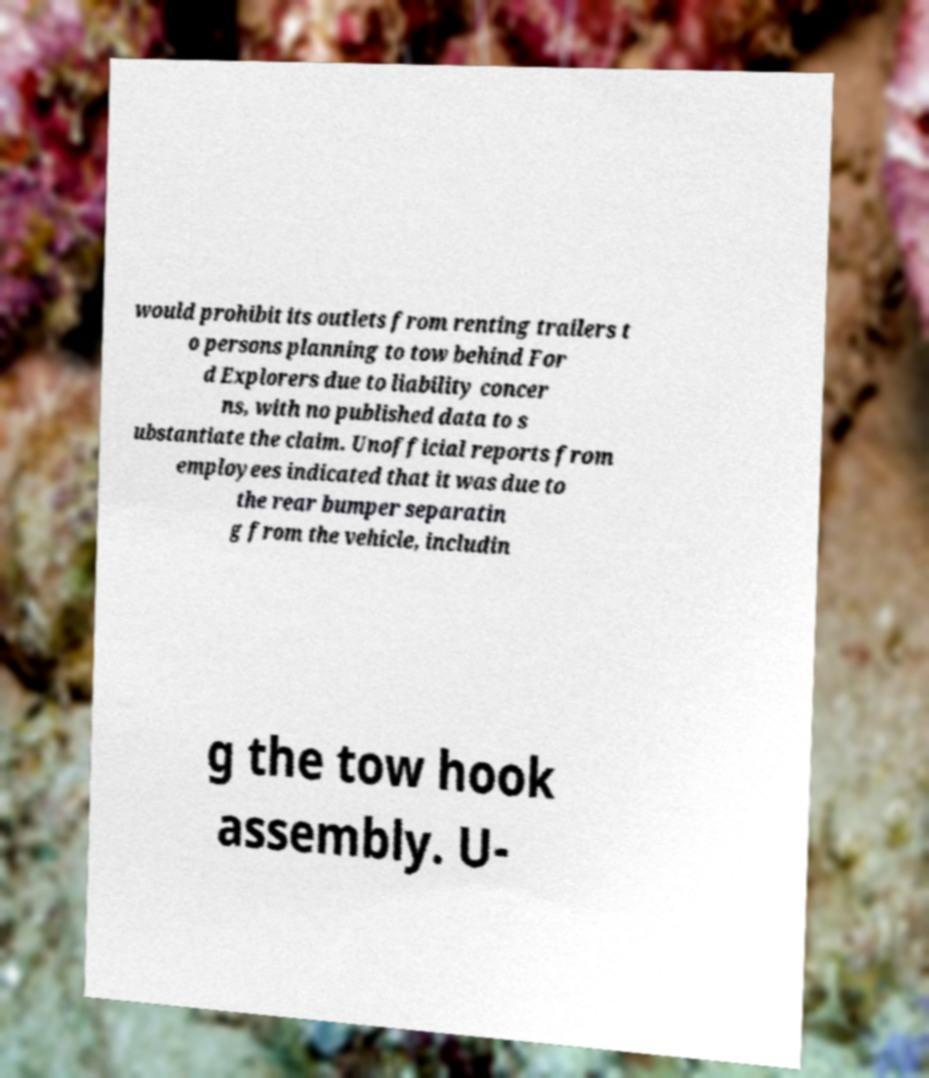Please read and relay the text visible in this image. What does it say? would prohibit its outlets from renting trailers t o persons planning to tow behind For d Explorers due to liability concer ns, with no published data to s ubstantiate the claim. Unofficial reports from employees indicated that it was due to the rear bumper separatin g from the vehicle, includin g the tow hook assembly. U- 